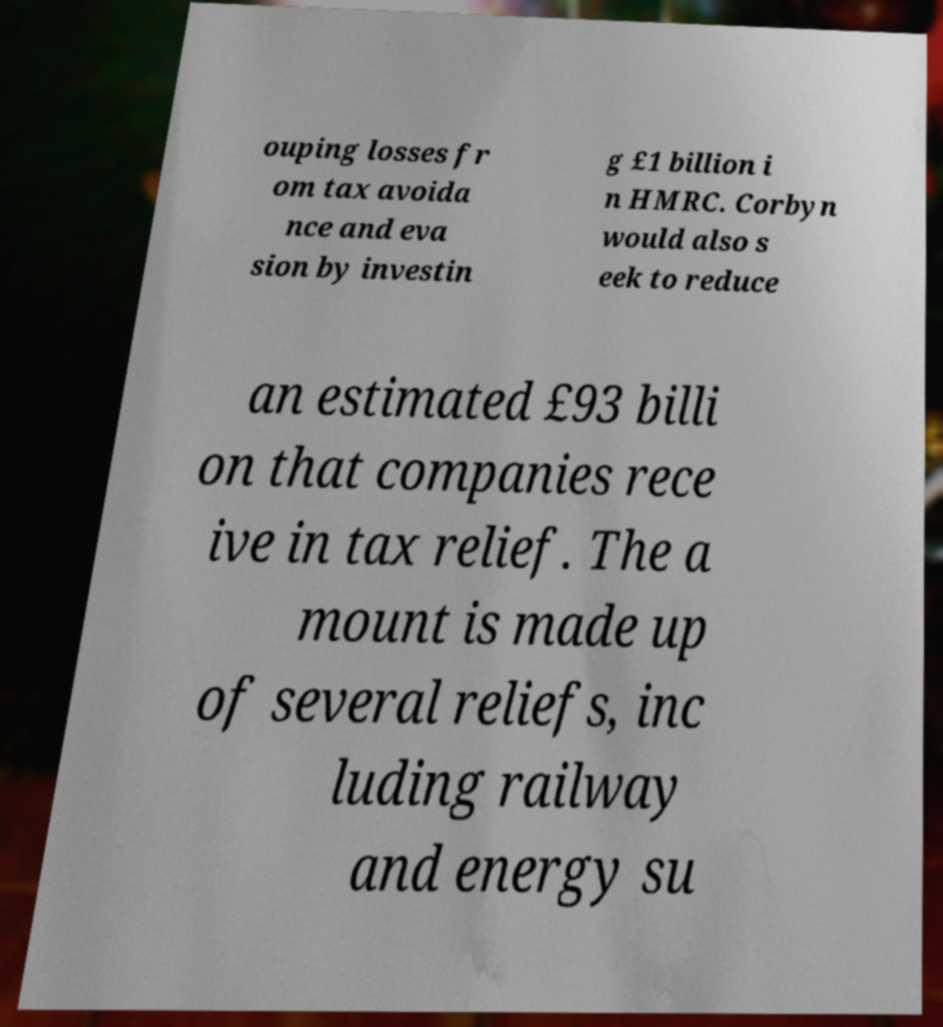Can you read and provide the text displayed in the image?This photo seems to have some interesting text. Can you extract and type it out for me? ouping losses fr om tax avoida nce and eva sion by investin g £1 billion i n HMRC. Corbyn would also s eek to reduce an estimated £93 billi on that companies rece ive in tax relief. The a mount is made up of several reliefs, inc luding railway and energy su 